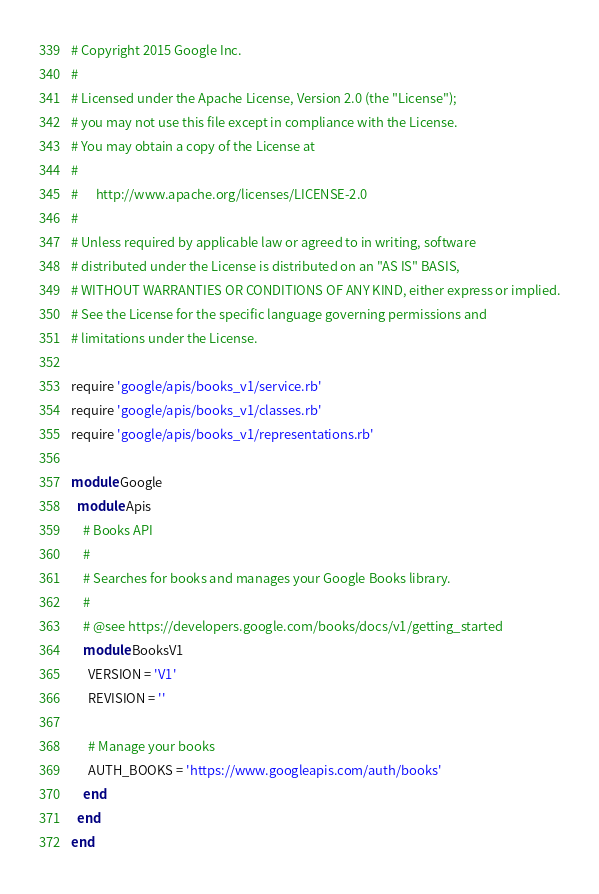Convert code to text. <code><loc_0><loc_0><loc_500><loc_500><_Ruby_># Copyright 2015 Google Inc.
#
# Licensed under the Apache License, Version 2.0 (the "License");
# you may not use this file except in compliance with the License.
# You may obtain a copy of the License at
#
#      http://www.apache.org/licenses/LICENSE-2.0
#
# Unless required by applicable law or agreed to in writing, software
# distributed under the License is distributed on an "AS IS" BASIS,
# WITHOUT WARRANTIES OR CONDITIONS OF ANY KIND, either express or implied.
# See the License for the specific language governing permissions and
# limitations under the License.

require 'google/apis/books_v1/service.rb'
require 'google/apis/books_v1/classes.rb'
require 'google/apis/books_v1/representations.rb'

module Google
  module Apis
    # Books API
    #
    # Searches for books and manages your Google Books library.
    #
    # @see https://developers.google.com/books/docs/v1/getting_started
    module BooksV1
      VERSION = 'V1'
      REVISION = ''

      # Manage your books
      AUTH_BOOKS = 'https://www.googleapis.com/auth/books'
    end
  end
end
</code> 